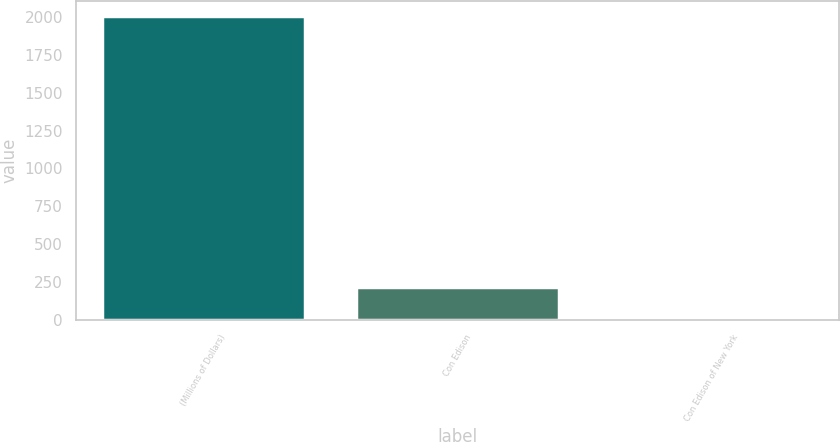<chart> <loc_0><loc_0><loc_500><loc_500><bar_chart><fcel>(Millions of Dollars)<fcel>Con Edison<fcel>Con Edison of New York<nl><fcel>2007<fcel>217.8<fcel>19<nl></chart> 